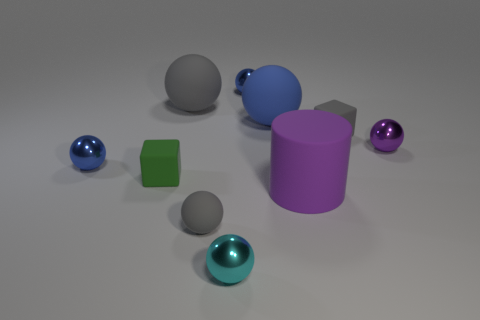Subtract 5 spheres. How many spheres are left? 2 Subtract all small cyan spheres. How many spheres are left? 6 Add 3 balls. How many balls are left? 10 Add 7 small green cylinders. How many small green cylinders exist? 7 Subtract all gray spheres. How many spheres are left? 5 Subtract 0 brown spheres. How many objects are left? 10 Subtract all balls. How many objects are left? 3 Subtract all blue cylinders. Subtract all blue balls. How many cylinders are left? 1 Subtract all blue spheres. How many brown cylinders are left? 0 Subtract all gray rubber things. Subtract all small rubber spheres. How many objects are left? 6 